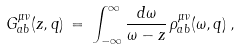<formula> <loc_0><loc_0><loc_500><loc_500>G _ { a b } ^ { \mu \nu } ( z , { q } ) \, = \, \int _ { - \infty } ^ { \infty } \frac { d \omega } { \omega - z } \, \rho ^ { \mu \nu } _ { a b } ( \omega , { q } ) \, ,</formula> 